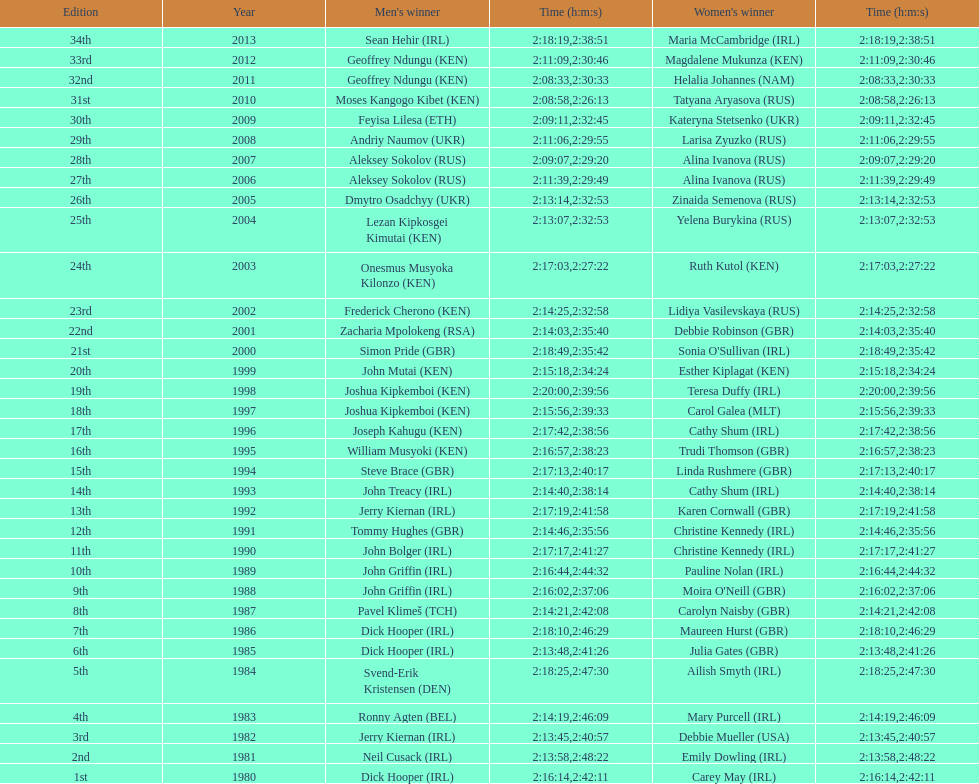Who had the longest duration among all the runners? Maria McCambridge (IRL). I'm looking to parse the entire table for insights. Could you assist me with that? {'header': ['Edition', 'Year', "Men's winner", 'Time (h:m:s)', "Women's winner", 'Time (h:m:s)'], 'rows': [['34th', '2013', 'Sean Hehir\xa0(IRL)', '2:18:19', 'Maria McCambridge\xa0(IRL)', '2:38:51'], ['33rd', '2012', 'Geoffrey Ndungu\xa0(KEN)', '2:11:09', 'Magdalene Mukunza\xa0(KEN)', '2:30:46'], ['32nd', '2011', 'Geoffrey Ndungu\xa0(KEN)', '2:08:33', 'Helalia Johannes\xa0(NAM)', '2:30:33'], ['31st', '2010', 'Moses Kangogo Kibet\xa0(KEN)', '2:08:58', 'Tatyana Aryasova\xa0(RUS)', '2:26:13'], ['30th', '2009', 'Feyisa Lilesa\xa0(ETH)', '2:09:11', 'Kateryna Stetsenko\xa0(UKR)', '2:32:45'], ['29th', '2008', 'Andriy Naumov\xa0(UKR)', '2:11:06', 'Larisa Zyuzko\xa0(RUS)', '2:29:55'], ['28th', '2007', 'Aleksey Sokolov\xa0(RUS)', '2:09:07', 'Alina Ivanova\xa0(RUS)', '2:29:20'], ['27th', '2006', 'Aleksey Sokolov\xa0(RUS)', '2:11:39', 'Alina Ivanova\xa0(RUS)', '2:29:49'], ['26th', '2005', 'Dmytro Osadchyy\xa0(UKR)', '2:13:14', 'Zinaida Semenova\xa0(RUS)', '2:32:53'], ['25th', '2004', 'Lezan Kipkosgei Kimutai\xa0(KEN)', '2:13:07', 'Yelena Burykina\xa0(RUS)', '2:32:53'], ['24th', '2003', 'Onesmus Musyoka Kilonzo\xa0(KEN)', '2:17:03', 'Ruth Kutol\xa0(KEN)', '2:27:22'], ['23rd', '2002', 'Frederick Cherono\xa0(KEN)', '2:14:25', 'Lidiya Vasilevskaya\xa0(RUS)', '2:32:58'], ['22nd', '2001', 'Zacharia Mpolokeng\xa0(RSA)', '2:14:03', 'Debbie Robinson\xa0(GBR)', '2:35:40'], ['21st', '2000', 'Simon Pride\xa0(GBR)', '2:18:49', "Sonia O'Sullivan\xa0(IRL)", '2:35:42'], ['20th', '1999', 'John Mutai\xa0(KEN)', '2:15:18', 'Esther Kiplagat\xa0(KEN)', '2:34:24'], ['19th', '1998', 'Joshua Kipkemboi\xa0(KEN)', '2:20:00', 'Teresa Duffy\xa0(IRL)', '2:39:56'], ['18th', '1997', 'Joshua Kipkemboi\xa0(KEN)', '2:15:56', 'Carol Galea\xa0(MLT)', '2:39:33'], ['17th', '1996', 'Joseph Kahugu\xa0(KEN)', '2:17:42', 'Cathy Shum\xa0(IRL)', '2:38:56'], ['16th', '1995', 'William Musyoki\xa0(KEN)', '2:16:57', 'Trudi Thomson\xa0(GBR)', '2:38:23'], ['15th', '1994', 'Steve Brace\xa0(GBR)', '2:17:13', 'Linda Rushmere\xa0(GBR)', '2:40:17'], ['14th', '1993', 'John Treacy\xa0(IRL)', '2:14:40', 'Cathy Shum\xa0(IRL)', '2:38:14'], ['13th', '1992', 'Jerry Kiernan\xa0(IRL)', '2:17:19', 'Karen Cornwall\xa0(GBR)', '2:41:58'], ['12th', '1991', 'Tommy Hughes\xa0(GBR)', '2:14:46', 'Christine Kennedy\xa0(IRL)', '2:35:56'], ['11th', '1990', 'John Bolger\xa0(IRL)', '2:17:17', 'Christine Kennedy\xa0(IRL)', '2:41:27'], ['10th', '1989', 'John Griffin\xa0(IRL)', '2:16:44', 'Pauline Nolan\xa0(IRL)', '2:44:32'], ['9th', '1988', 'John Griffin\xa0(IRL)', '2:16:02', "Moira O'Neill\xa0(GBR)", '2:37:06'], ['8th', '1987', 'Pavel Klimeš\xa0(TCH)', '2:14:21', 'Carolyn Naisby\xa0(GBR)', '2:42:08'], ['7th', '1986', 'Dick Hooper\xa0(IRL)', '2:18:10', 'Maureen Hurst\xa0(GBR)', '2:46:29'], ['6th', '1985', 'Dick Hooper\xa0(IRL)', '2:13:48', 'Julia Gates\xa0(GBR)', '2:41:26'], ['5th', '1984', 'Svend-Erik Kristensen\xa0(DEN)', '2:18:25', 'Ailish Smyth\xa0(IRL)', '2:47:30'], ['4th', '1983', 'Ronny Agten\xa0(BEL)', '2:14:19', 'Mary Purcell\xa0(IRL)', '2:46:09'], ['3rd', '1982', 'Jerry Kiernan\xa0(IRL)', '2:13:45', 'Debbie Mueller\xa0(USA)', '2:40:57'], ['2nd', '1981', 'Neil Cusack\xa0(IRL)', '2:13:58', 'Emily Dowling\xa0(IRL)', '2:48:22'], ['1st', '1980', 'Dick Hooper\xa0(IRL)', '2:16:14', 'Carey May\xa0(IRL)', '2:42:11']]} 